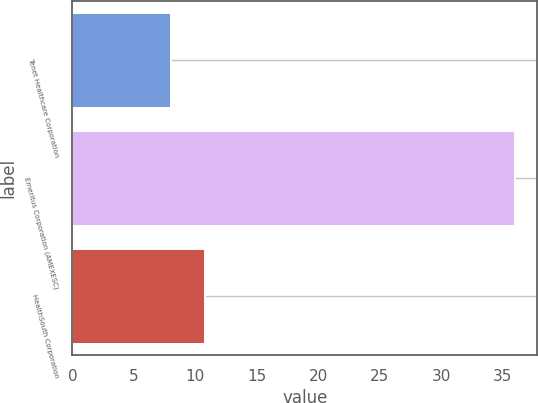<chart> <loc_0><loc_0><loc_500><loc_500><bar_chart><fcel>Tenet Healthcare Corporation<fcel>Emeritus Corporation (AMEXESC)<fcel>HealthSouth Corporation<nl><fcel>8<fcel>36<fcel>10.8<nl></chart> 